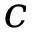Convert formula to latex. <formula><loc_0><loc_0><loc_500><loc_500>c</formula> 